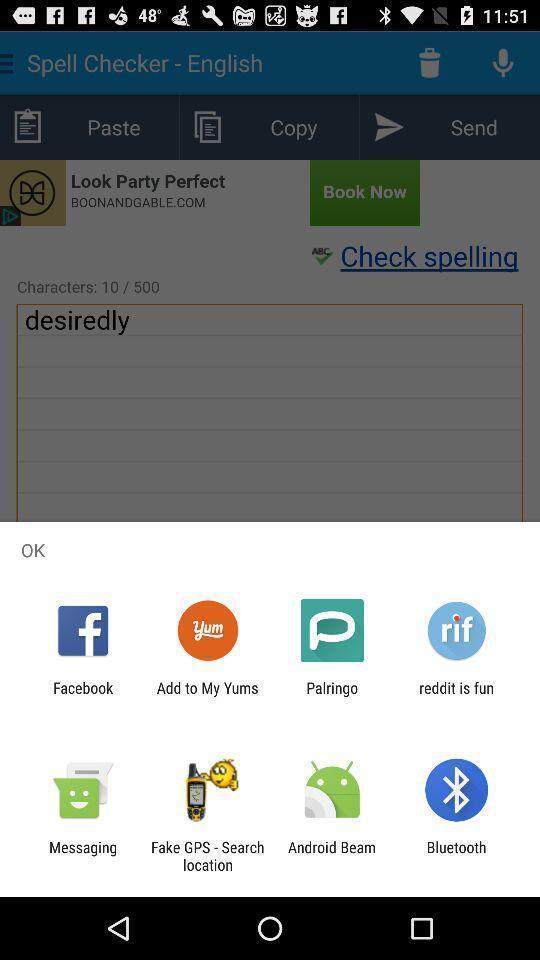Tell me about the visual elements in this screen capture. Pop-up widget is showing many sharing apps. 